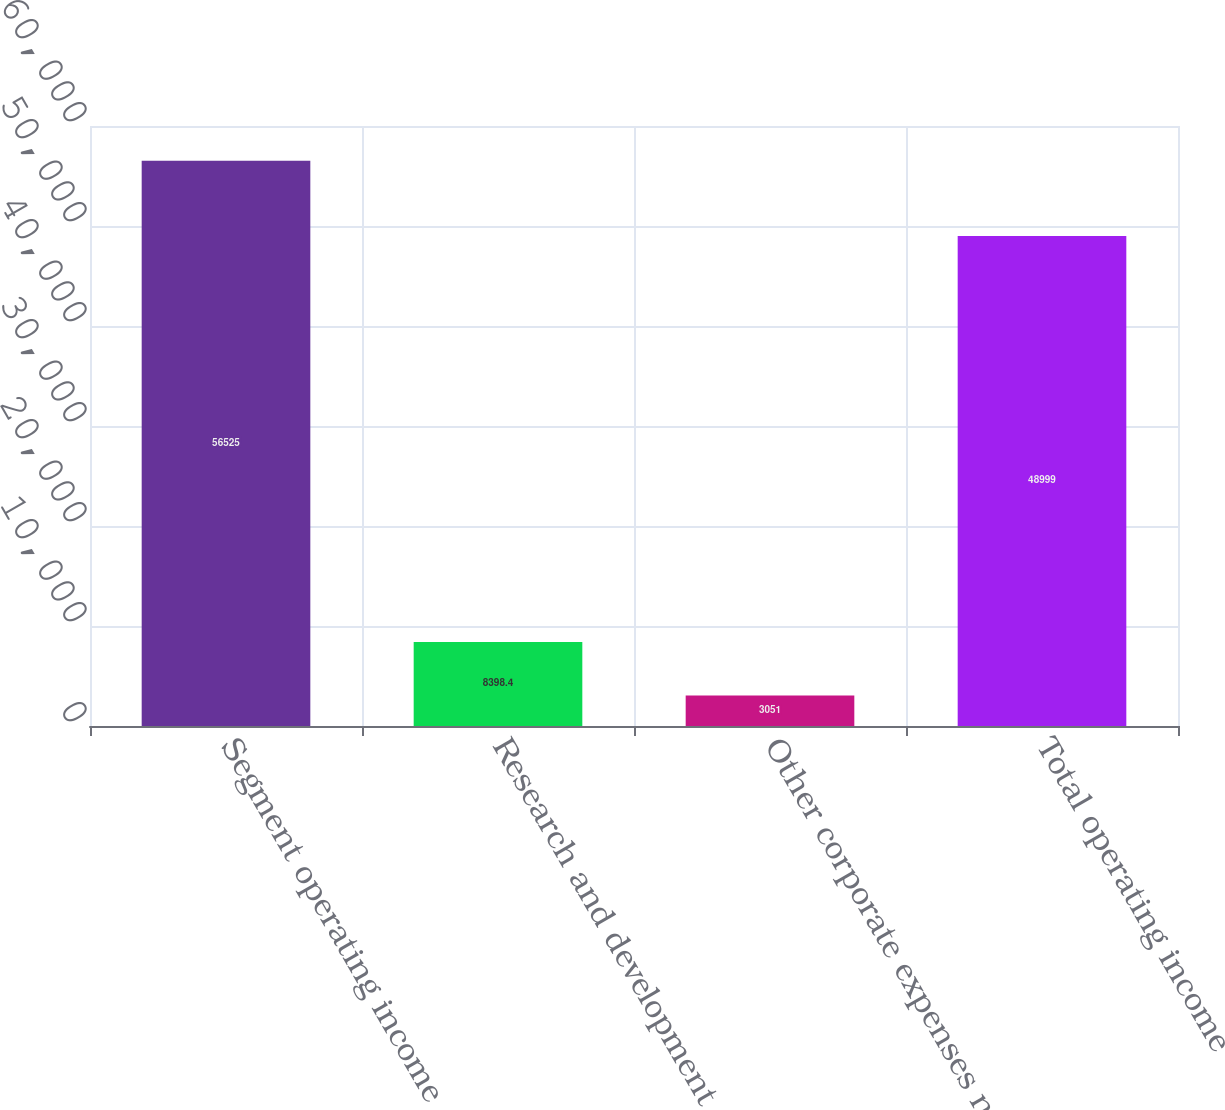<chart> <loc_0><loc_0><loc_500><loc_500><bar_chart><fcel>Segment operating income<fcel>Research and development<fcel>Other corporate expenses net<fcel>Total operating income<nl><fcel>56525<fcel>8398.4<fcel>3051<fcel>48999<nl></chart> 